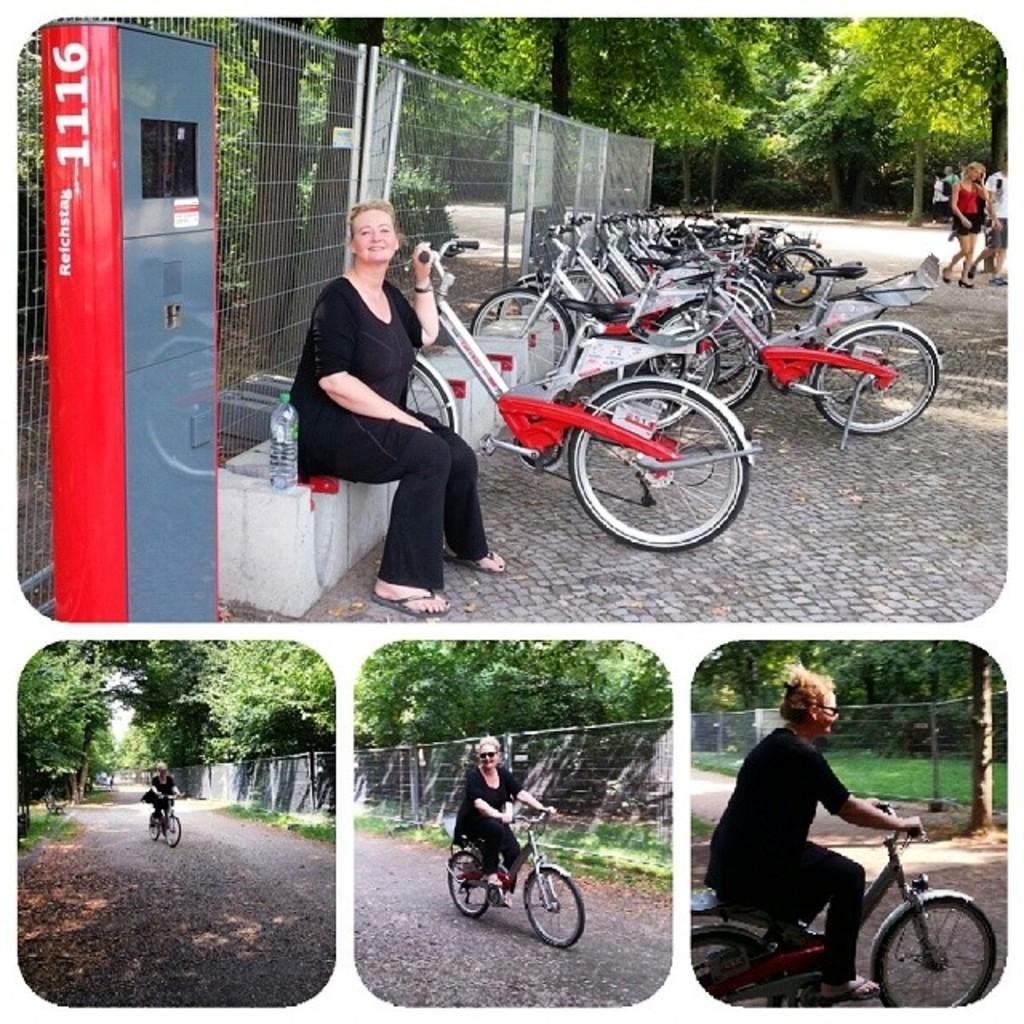In one or two sentences, can you explain what this image depicts? This image is clicked outside and edited in college. In the image there is a woman sitting and wearing a black dress. And she is also riding the bicycle. In the background, there are trees and bicycles. 